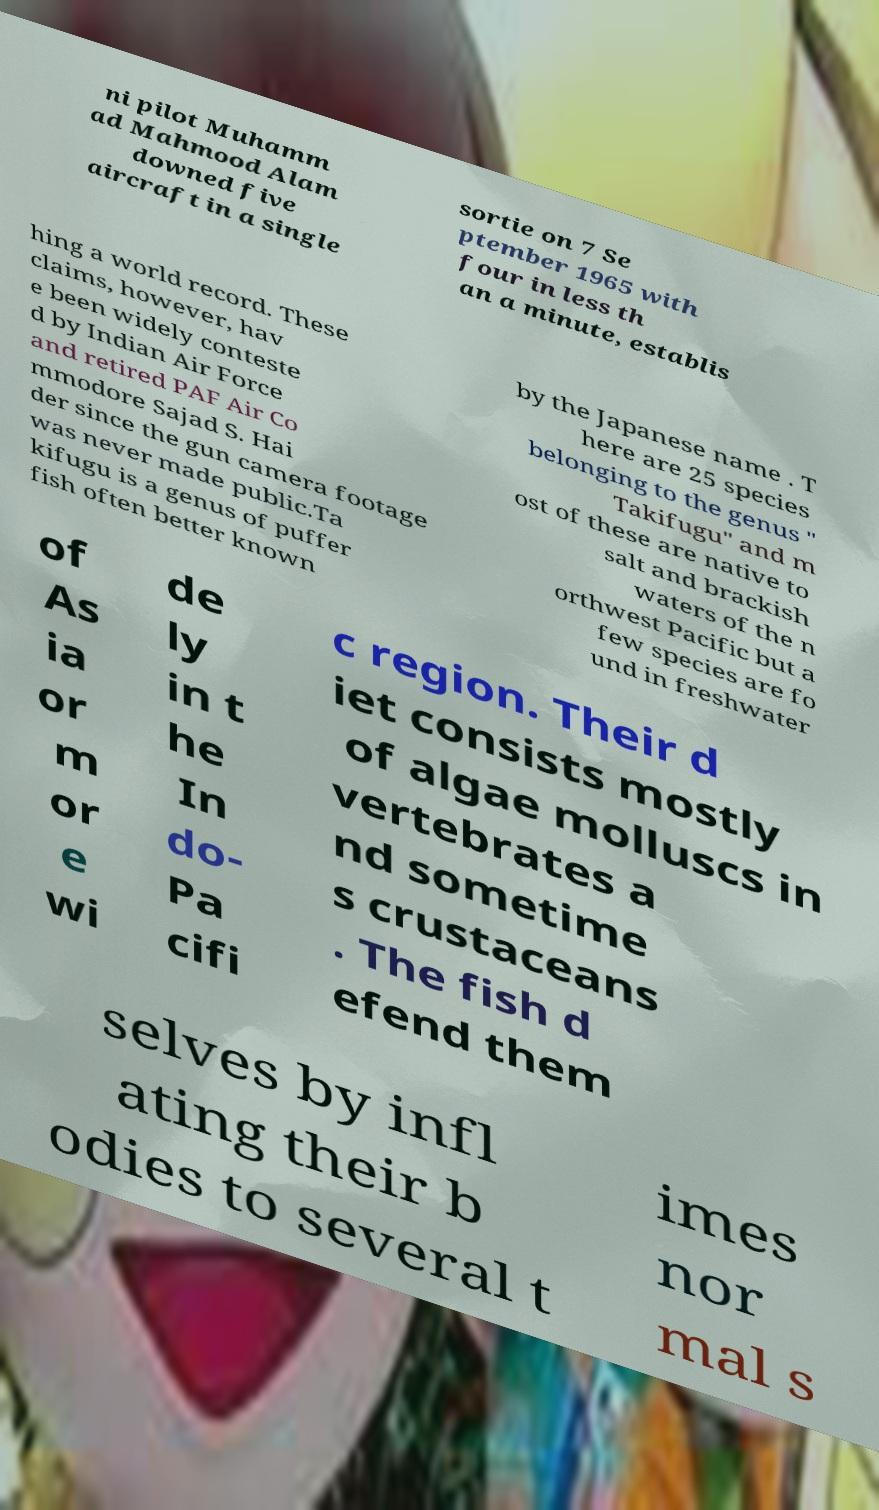Please identify and transcribe the text found in this image. ni pilot Muhamm ad Mahmood Alam downed five aircraft in a single sortie on 7 Se ptember 1965 with four in less th an a minute, establis hing a world record. These claims, however, hav e been widely conteste d by Indian Air Force and retired PAF Air Co mmodore Sajad S. Hai der since the gun camera footage was never made public.Ta kifugu is a genus of puffer fish often better known by the Japanese name . T here are 25 species belonging to the genus " Takifugu" and m ost of these are native to salt and brackish waters of the n orthwest Pacific but a few species are fo und in freshwater of As ia or m or e wi de ly in t he In do- Pa cifi c region. Their d iet consists mostly of algae molluscs in vertebrates a nd sometime s crustaceans . The fish d efend them selves by infl ating their b odies to several t imes nor mal s 